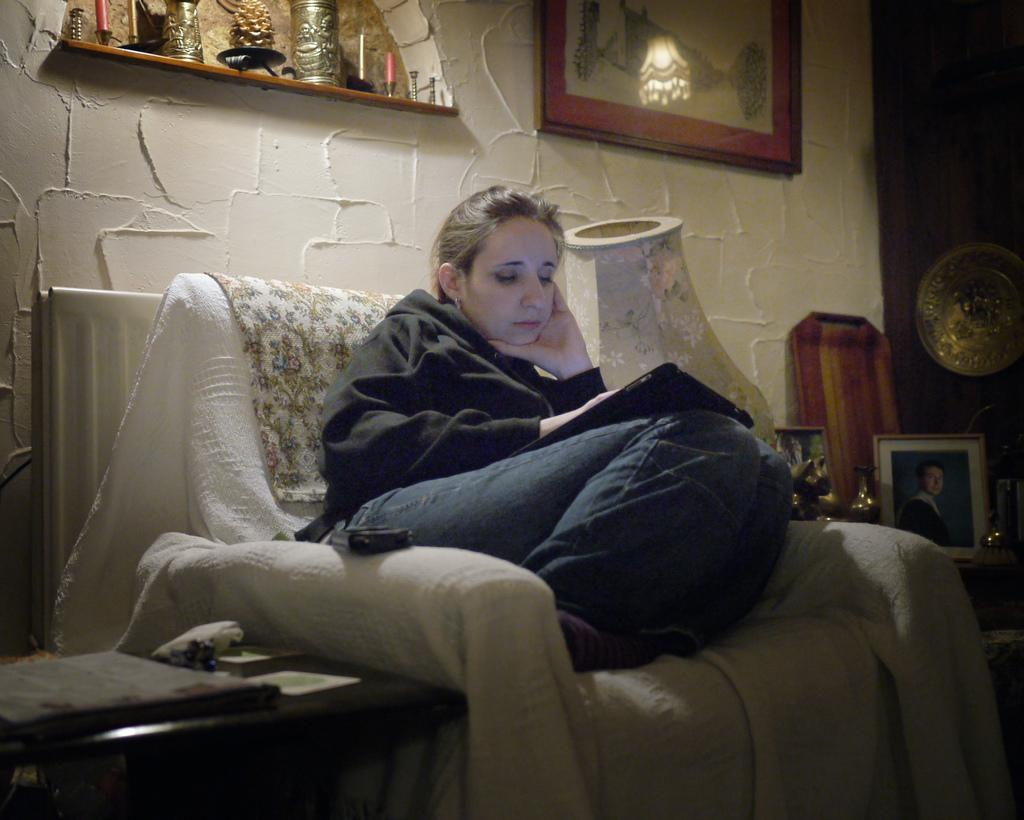What is the woman in the image doing? The woman is sitting on the couch in the center of the image and holding a book. What can be seen in the background of the image? There is a wall, a photo frame, a table, a plate, a lamp, and cloth in the background of the image. Can you describe the objects on the table in the background? Unfortunately, the facts provided do not specify the objects on the table. What might the woman be reading in the book? The facts provided do not give any information about the content of the book. What type of heat can be felt coming from the cakes in the image? There are no cakes present in the image, so it is not possible to determine what type of heat might be felt. 